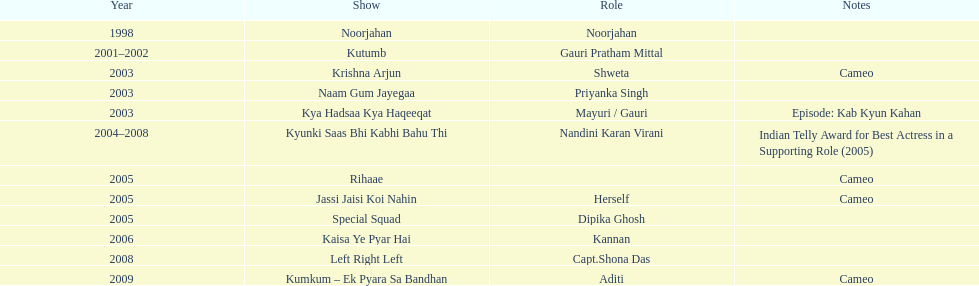The show above left right left Kaisa Ye Pyar Hai. 